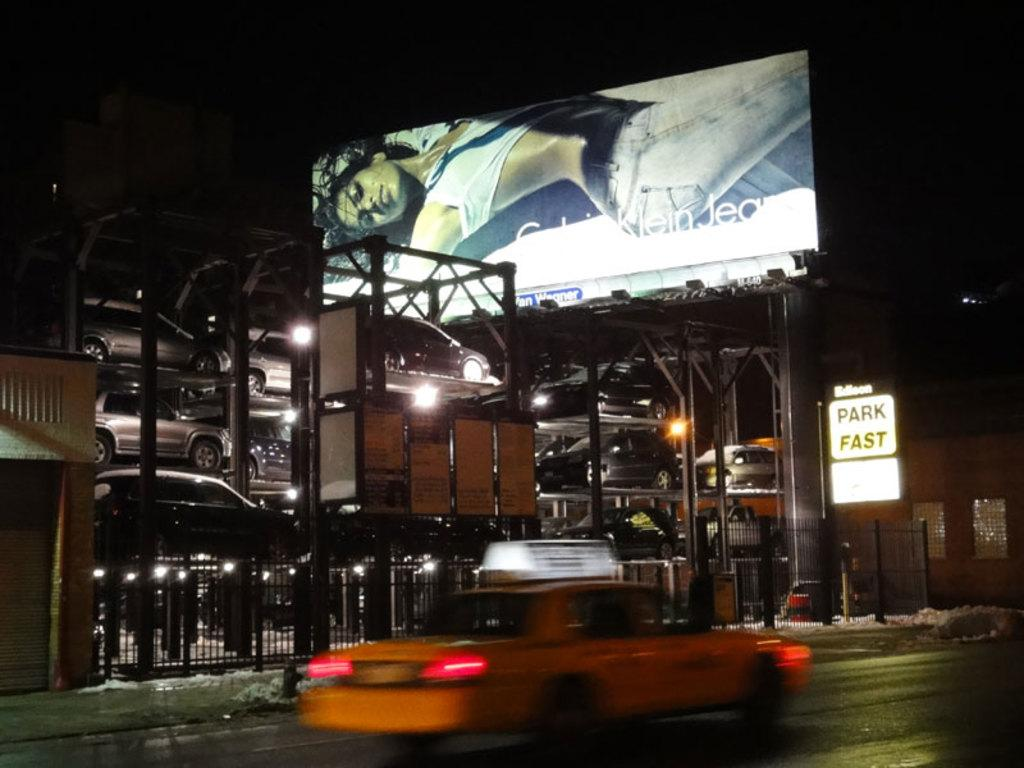Provide a one-sentence caption for the provided image. The billboard above the parking garage is advertising Calvin Klein jeans. 